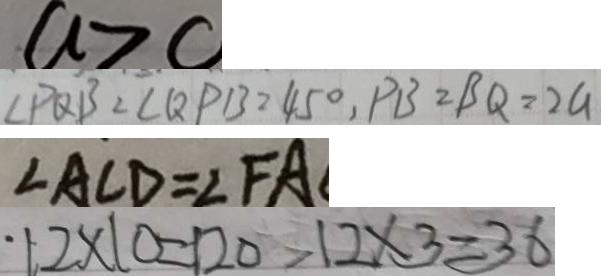Convert formula to latex. <formula><loc_0><loc_0><loc_500><loc_500>a > c 
 \angle P Q B = \angle Q P B = 4 5 ^ { \circ } , P B = B Q = 2 G 
 \angle A C D = \angle F A 
 1 2 \times 1 0 = 1 2 0 > 1 2 \times 3 = 3 6</formula> 